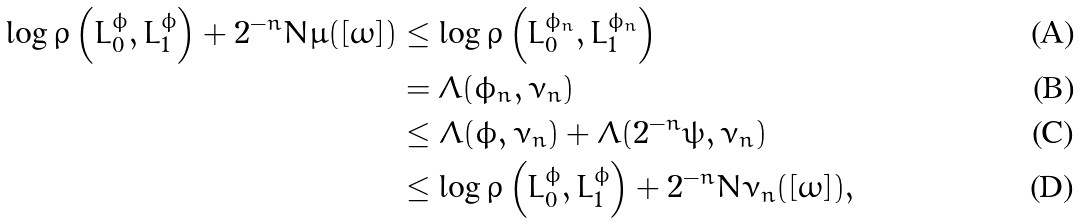<formula> <loc_0><loc_0><loc_500><loc_500>\log \varrho \left ( L _ { 0 } ^ { \phi } , L _ { 1 } ^ { \phi } \right ) + 2 ^ { - n } N \mu ( [ \omega ] ) & \leq \log \varrho \left ( L _ { 0 } ^ { \phi _ { n } } , L _ { 1 } ^ { \phi _ { n } } \right ) \\ & = \Lambda ( \phi _ { n } , \nu _ { n } ) \\ & \leq \Lambda ( \phi , \nu _ { n } ) + \Lambda ( 2 ^ { - n } \psi , \nu _ { n } ) \\ & \leq \log \varrho \left ( L _ { 0 } ^ { \phi } , L _ { 1 } ^ { \phi } \right ) + 2 ^ { - n } N \nu _ { n } ( [ \omega ] ) ,</formula> 